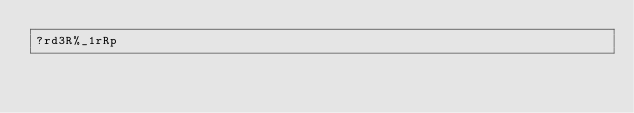<code> <loc_0><loc_0><loc_500><loc_500><_dc_>?rd3R%_1rRp</code> 